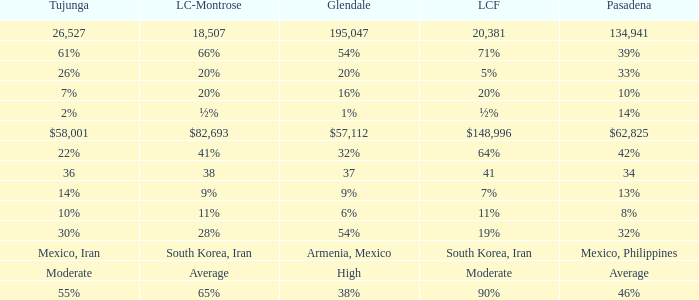What is the figure for La Canada Flintridge when Pasadena is 34? 41.0. 